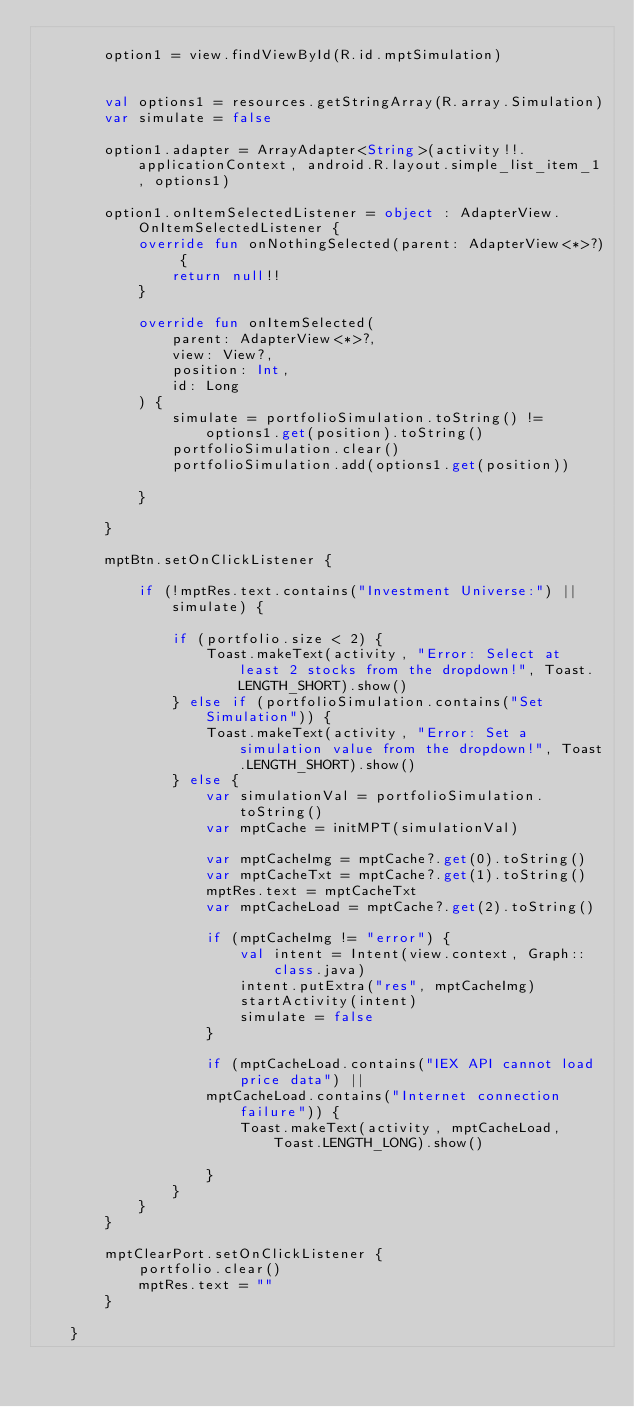Convert code to text. <code><loc_0><loc_0><loc_500><loc_500><_Kotlin_>
        option1 = view.findViewById(R.id.mptSimulation)


        val options1 = resources.getStringArray(R.array.Simulation)
        var simulate = false

        option1.adapter = ArrayAdapter<String>(activity!!.applicationContext, android.R.layout.simple_list_item_1, options1)

        option1.onItemSelectedListener = object : AdapterView.OnItemSelectedListener {
            override fun onNothingSelected(parent: AdapterView<*>?) {
                return null!!
            }

            override fun onItemSelected(
                parent: AdapterView<*>?,
                view: View?,
                position: Int,
                id: Long
            ) {
                simulate = portfolioSimulation.toString() != options1.get(position).toString()
                portfolioSimulation.clear()
                portfolioSimulation.add(options1.get(position))

            }

        }

        mptBtn.setOnClickListener {

            if (!mptRes.text.contains("Investment Universe:") || simulate) {

                if (portfolio.size < 2) {
                    Toast.makeText(activity, "Error: Select at least 2 stocks from the dropdown!", Toast.LENGTH_SHORT).show()
                } else if (portfolioSimulation.contains("Set Simulation")) {
                    Toast.makeText(activity, "Error: Set a simulation value from the dropdown!", Toast.LENGTH_SHORT).show()
                } else {
                    var simulationVal = portfolioSimulation.toString()
                    var mptCache = initMPT(simulationVal)

                    var mptCacheImg = mptCache?.get(0).toString()
                    var mptCacheTxt = mptCache?.get(1).toString()
                    mptRes.text = mptCacheTxt
                    var mptCacheLoad = mptCache?.get(2).toString()

                    if (mptCacheImg != "error") {
                        val intent = Intent(view.context, Graph::class.java)
                        intent.putExtra("res", mptCacheImg)
                        startActivity(intent)
                        simulate = false
                    }

                    if (mptCacheLoad.contains("IEX API cannot load price data") ||
                    mptCacheLoad.contains("Internet connection failure")) {
                        Toast.makeText(activity, mptCacheLoad, Toast.LENGTH_LONG).show()

                    }
                }
            }
        }

        mptClearPort.setOnClickListener {
            portfolio.clear()
            mptRes.text = ""
        }

    }
</code> 